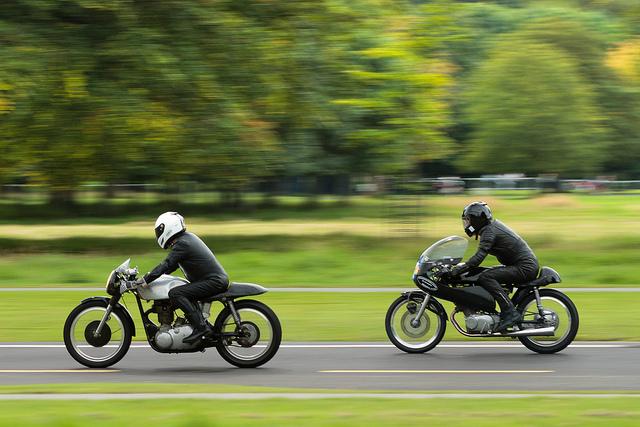What are they riding?
Write a very short answer. Motorcycles. Are they racing on a beach?
Keep it brief. No. Is the photo blurry?
Answer briefly. Yes. What do the riders have on their heads?
Keep it brief. Helmets. 